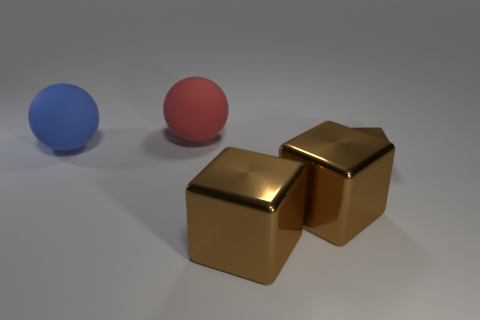What number of other objects are there of the same size as the red thing?
Offer a very short reply. 3. How many small objects are either blue matte spheres or brown things?
Ensure brevity in your answer.  1. There is a large matte thing that is right of the big blue matte thing; what is its shape?
Your answer should be very brief. Sphere. What number of cyan cylinders are there?
Give a very brief answer. 0. Are the blue thing and the tiny brown thing made of the same material?
Offer a very short reply. No. Are there more large things in front of the red rubber sphere than large brown cubes?
Offer a terse response. Yes. What number of objects are either small brown metal things or metallic cubes to the left of the small brown object?
Keep it short and to the point. 3. Are there more large matte spheres behind the large blue matte sphere than tiny things to the left of the small brown shiny block?
Ensure brevity in your answer.  Yes. There is a object that is to the left of the big thing that is behind the matte sphere that is in front of the large red rubber sphere; what is it made of?
Provide a succinct answer. Rubber. What is the shape of the other thing that is made of the same material as the red thing?
Provide a succinct answer. Sphere. 